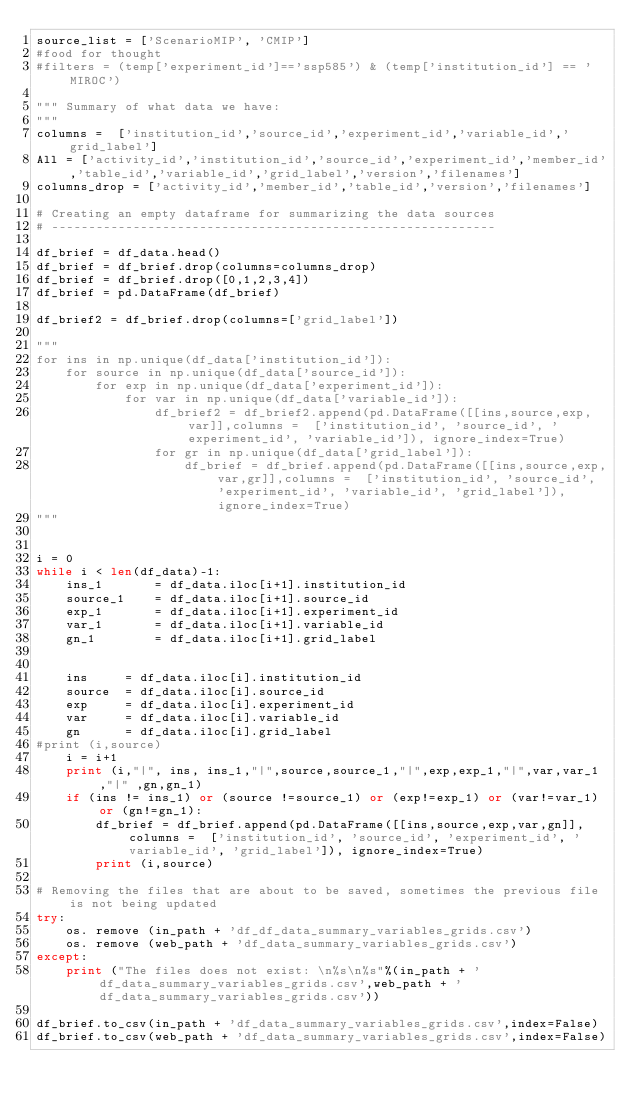Convert code to text. <code><loc_0><loc_0><loc_500><loc_500><_Python_>source_list = ['ScenarioMIP', 'CMIP']
#food for thought
#filters = (temp['experiment_id']=='ssp585') & (temp['institution_id'] == 'MIROC')
		
""" Summary of what data we have:
"""
columns =  ['institution_id','source_id','experiment_id','variable_id','grid_label']
All = ['activity_id','institution_id','source_id','experiment_id','member_id','table_id','variable_id','grid_label','version','filenames']
columns_drop = ['activity_id','member_id','table_id','version','filenames']

# Creating an empty dataframe for summarizing the data sources
# ------------------------------------------------------------

df_brief = df_data.head()
df_brief = df_brief.drop(columns=columns_drop) 
df_brief = df_brief.drop([0,1,2,3,4])      
df_brief = pd.DataFrame(df_brief) 

df_brief2 = df_brief.drop(columns=['grid_label'])     

"""
for ins in np.unique(df_data['institution_id']):
	for source in np.unique(df_data['source_id']):
		for exp in np.unique(df_data['experiment_id']):
			for var in np.unique(df_data['variable_id']):
				df_brief2 = df_brief2.append(pd.DataFrame([[ins,source,exp,var]],columns =  ['institution_id', 'source_id', 'experiment_id', 'variable_id']), ignore_index=True)
				for gr in np.unique(df_data['grid_label']):
					df_brief = df_brief.append(pd.DataFrame([[ins,source,exp,var,gr]],columns =  ['institution_id', 'source_id', 'experiment_id', 'variable_id', 'grid_label']), ignore_index=True)
"""


i = 0
while i < len(df_data)-1:
	ins_1 		= df_data.iloc[i+1].institution_id
	source_1 	= df_data.iloc[i+1].source_id
	exp_1 		= df_data.iloc[i+1].experiment_id
	var_1		= df_data.iloc[i+1].variable_id
	gn_1 		= df_data.iloc[i+1].grid_label


	ins 	= df_data.iloc[i].institution_id
	source 	= df_data.iloc[i].source_id
	exp 	= df_data.iloc[i].experiment_id
	var 	= df_data.iloc[i].variable_id
	gn 		= df_data.iloc[i].grid_label
#print (i,source)
	i = i+1
	print (i,"|", ins, ins_1,"|",source,source_1,"|",exp,exp_1,"|",var,var_1 ,"|" ,gn,gn_1)
	if (ins != ins_1) or (source !=source_1) or (exp!=exp_1) or (var!=var_1) or (gn!=gn_1):
		df_brief = df_brief.append(pd.DataFrame([[ins,source,exp,var,gn]],columns =  ['institution_id', 'source_id', 'experiment_id', 'variable_id', 'grid_label']), ignore_index=True)
		print (i,source)

# Removing the files that are about to be saved, sometimes the previous file is not being updated		
try:
	os. remove (in_path + 'df_df_data_summary_variables_grids.csv')
	os. remove (web_path + 'df_data_summary_variables_grids.csv')
except:
	print ("The files does not exist: \n%s\n%s"%(in_path + 'df_data_summary_variables_grids.csv',web_path + 'df_data_summary_variables_grids.csv'))

df_brief.to_csv(in_path + 'df_data_summary_variables_grids.csv',index=False)
df_brief.to_csv(web_path + 'df_data_summary_variables_grids.csv',index=False)
</code> 